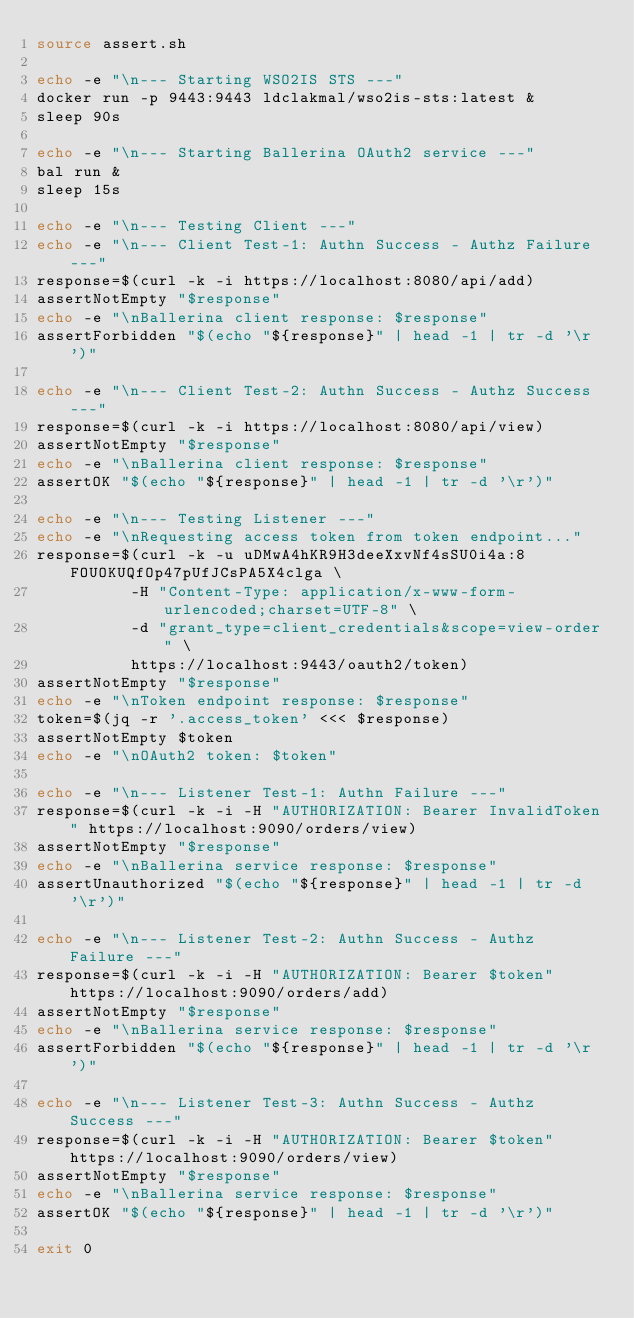<code> <loc_0><loc_0><loc_500><loc_500><_Bash_>source assert.sh

echo -e "\n--- Starting WSO2IS STS ---"
docker run -p 9443:9443 ldclakmal/wso2is-sts:latest &
sleep 90s

echo -e "\n--- Starting Ballerina OAuth2 service ---"
bal run &
sleep 15s

echo -e "\n--- Testing Client ---"
echo -e "\n--- Client Test-1: Authn Success - Authz Failure ---"
response=$(curl -k -i https://localhost:8080/api/add)
assertNotEmpty "$response"
echo -e "\nBallerina client response: $response"
assertForbidden "$(echo "${response}" | head -1 | tr -d '\r')"

echo -e "\n--- Client Test-2: Authn Success - Authz Success ---"
response=$(curl -k -i https://localhost:8080/api/view)
assertNotEmpty "$response"
echo -e "\nBallerina client response: $response"
assertOK "$(echo "${response}" | head -1 | tr -d '\r')"

echo -e "\n--- Testing Listener ---"
echo -e "\nRequesting access token from token endpoint..."
response=$(curl -k -u uDMwA4hKR9H3deeXxvNf4sSU0i4a:8FOUOKUQfOp47pUfJCsPA5X4clga \
          -H "Content-Type: application/x-www-form-urlencoded;charset=UTF-8" \
          -d "grant_type=client_credentials&scope=view-order" \
          https://localhost:9443/oauth2/token)
assertNotEmpty "$response"
echo -e "\nToken endpoint response: $response"
token=$(jq -r '.access_token' <<< $response)
assertNotEmpty $token
echo -e "\nOAuth2 token: $token"

echo -e "\n--- Listener Test-1: Authn Failure ---"
response=$(curl -k -i -H "AUTHORIZATION: Bearer InvalidToken" https://localhost:9090/orders/view)
assertNotEmpty "$response"
echo -e "\nBallerina service response: $response"
assertUnauthorized "$(echo "${response}" | head -1 | tr -d '\r')"

echo -e "\n--- Listener Test-2: Authn Success - Authz Failure ---"
response=$(curl -k -i -H "AUTHORIZATION: Bearer $token" https://localhost:9090/orders/add)
assertNotEmpty "$response"
echo -e "\nBallerina service response: $response"
assertForbidden "$(echo "${response}" | head -1 | tr -d '\r')"

echo -e "\n--- Listener Test-3: Authn Success - Authz Success ---"
response=$(curl -k -i -H "AUTHORIZATION: Bearer $token" https://localhost:9090/orders/view)
assertNotEmpty "$response"
echo -e "\nBallerina service response: $response"
assertOK "$(echo "${response}" | head -1 | tr -d '\r')"

exit 0
</code> 